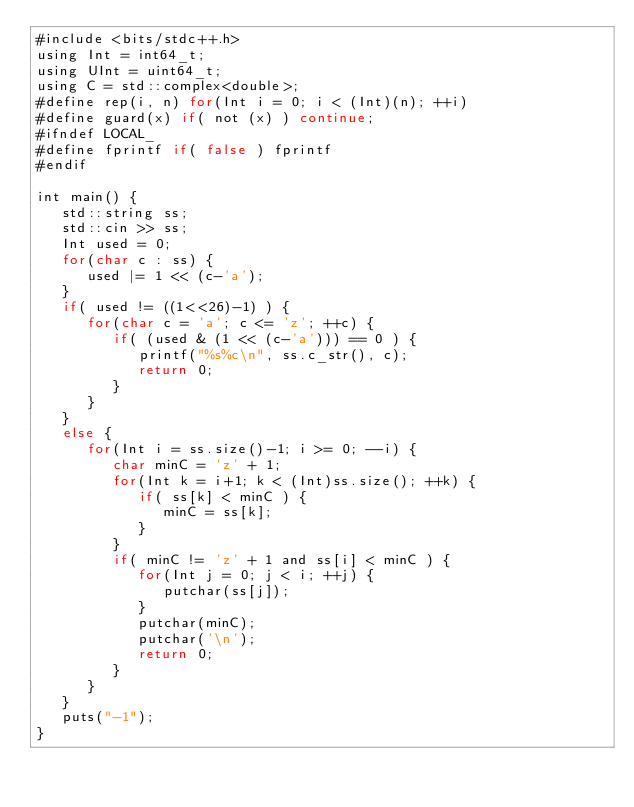<code> <loc_0><loc_0><loc_500><loc_500><_Rust_>#include <bits/stdc++.h>
using Int = int64_t;
using UInt = uint64_t;
using C = std::complex<double>;
#define rep(i, n) for(Int i = 0; i < (Int)(n); ++i)
#define guard(x) if( not (x) ) continue;
#ifndef LOCAL_
#define fprintf if( false ) fprintf
#endif

int main() {
   std::string ss;
   std::cin >> ss;
   Int used = 0;
   for(char c : ss) {
      used |= 1 << (c-'a');
   }
   if( used != ((1<<26)-1) ) {
      for(char c = 'a'; c <= 'z'; ++c) {
         if( (used & (1 << (c-'a'))) == 0 ) {
            printf("%s%c\n", ss.c_str(), c);
            return 0;
         }
      }
   }
   else {
      for(Int i = ss.size()-1; i >= 0; --i) {
         char minC = 'z' + 1;
         for(Int k = i+1; k < (Int)ss.size(); ++k) {
            if( ss[k] < minC ) {
               minC = ss[k];
            }
         }
         if( minC != 'z' + 1 and ss[i] < minC ) {
            for(Int j = 0; j < i; ++j) {
               putchar(ss[j]);
            }
            putchar(minC);
            putchar('\n');
            return 0;
         }
      }
   }
   puts("-1");
}
</code> 